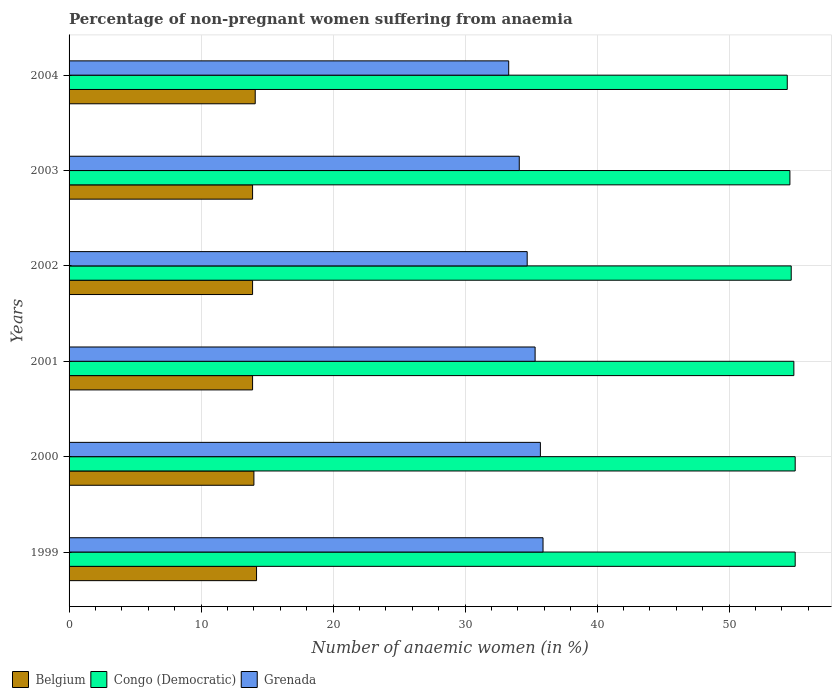How many different coloured bars are there?
Make the answer very short. 3. Are the number of bars on each tick of the Y-axis equal?
Ensure brevity in your answer.  Yes. How many bars are there on the 1st tick from the bottom?
Your response must be concise. 3. What is the label of the 1st group of bars from the top?
Offer a very short reply. 2004. What is the percentage of non-pregnant women suffering from anaemia in Congo (Democratic) in 2001?
Your response must be concise. 54.9. Across all years, what is the maximum percentage of non-pregnant women suffering from anaemia in Belgium?
Give a very brief answer. 14.2. Across all years, what is the minimum percentage of non-pregnant women suffering from anaemia in Congo (Democratic)?
Offer a terse response. 54.4. What is the total percentage of non-pregnant women suffering from anaemia in Belgium in the graph?
Provide a succinct answer. 84. What is the difference between the percentage of non-pregnant women suffering from anaemia in Grenada in 2002 and that in 2004?
Offer a very short reply. 1.4. What is the difference between the percentage of non-pregnant women suffering from anaemia in Grenada in 2003 and the percentage of non-pregnant women suffering from anaemia in Belgium in 2002?
Provide a short and direct response. 20.2. What is the average percentage of non-pregnant women suffering from anaemia in Congo (Democratic) per year?
Offer a very short reply. 54.77. In the year 2000, what is the difference between the percentage of non-pregnant women suffering from anaemia in Congo (Democratic) and percentage of non-pregnant women suffering from anaemia in Grenada?
Your answer should be compact. 19.3. In how many years, is the percentage of non-pregnant women suffering from anaemia in Grenada greater than 50 %?
Your response must be concise. 0. What is the ratio of the percentage of non-pregnant women suffering from anaemia in Grenada in 2001 to that in 2004?
Provide a short and direct response. 1.06. Is the percentage of non-pregnant women suffering from anaemia in Belgium in 1999 less than that in 2001?
Your response must be concise. No. What is the difference between the highest and the second highest percentage of non-pregnant women suffering from anaemia in Belgium?
Your answer should be very brief. 0.1. What is the difference between the highest and the lowest percentage of non-pregnant women suffering from anaemia in Belgium?
Give a very brief answer. 0.3. Is the sum of the percentage of non-pregnant women suffering from anaemia in Grenada in 1999 and 2004 greater than the maximum percentage of non-pregnant women suffering from anaemia in Belgium across all years?
Your response must be concise. Yes. What does the 1st bar from the top in 2000 represents?
Make the answer very short. Grenada. What does the 2nd bar from the bottom in 2002 represents?
Your response must be concise. Congo (Democratic). Is it the case that in every year, the sum of the percentage of non-pregnant women suffering from anaemia in Belgium and percentage of non-pregnant women suffering from anaemia in Congo (Democratic) is greater than the percentage of non-pregnant women suffering from anaemia in Grenada?
Your answer should be very brief. Yes. Are all the bars in the graph horizontal?
Ensure brevity in your answer.  Yes. Are the values on the major ticks of X-axis written in scientific E-notation?
Offer a very short reply. No. How many legend labels are there?
Make the answer very short. 3. What is the title of the graph?
Your response must be concise. Percentage of non-pregnant women suffering from anaemia. Does "Madagascar" appear as one of the legend labels in the graph?
Make the answer very short. No. What is the label or title of the X-axis?
Make the answer very short. Number of anaemic women (in %). What is the label or title of the Y-axis?
Provide a succinct answer. Years. What is the Number of anaemic women (in %) in Congo (Democratic) in 1999?
Make the answer very short. 55. What is the Number of anaemic women (in %) of Grenada in 1999?
Provide a succinct answer. 35.9. What is the Number of anaemic women (in %) in Belgium in 2000?
Your answer should be compact. 14. What is the Number of anaemic women (in %) of Grenada in 2000?
Your answer should be very brief. 35.7. What is the Number of anaemic women (in %) of Belgium in 2001?
Give a very brief answer. 13.9. What is the Number of anaemic women (in %) of Congo (Democratic) in 2001?
Offer a very short reply. 54.9. What is the Number of anaemic women (in %) in Grenada in 2001?
Your answer should be compact. 35.3. What is the Number of anaemic women (in %) of Congo (Democratic) in 2002?
Your response must be concise. 54.7. What is the Number of anaemic women (in %) in Grenada in 2002?
Make the answer very short. 34.7. What is the Number of anaemic women (in %) in Congo (Democratic) in 2003?
Offer a terse response. 54.6. What is the Number of anaemic women (in %) in Grenada in 2003?
Offer a very short reply. 34.1. What is the Number of anaemic women (in %) in Congo (Democratic) in 2004?
Provide a short and direct response. 54.4. What is the Number of anaemic women (in %) of Grenada in 2004?
Offer a terse response. 33.3. Across all years, what is the maximum Number of anaemic women (in %) in Belgium?
Offer a very short reply. 14.2. Across all years, what is the maximum Number of anaemic women (in %) of Congo (Democratic)?
Your answer should be very brief. 55. Across all years, what is the maximum Number of anaemic women (in %) in Grenada?
Ensure brevity in your answer.  35.9. Across all years, what is the minimum Number of anaemic women (in %) of Congo (Democratic)?
Give a very brief answer. 54.4. Across all years, what is the minimum Number of anaemic women (in %) of Grenada?
Make the answer very short. 33.3. What is the total Number of anaemic women (in %) of Congo (Democratic) in the graph?
Make the answer very short. 328.6. What is the total Number of anaemic women (in %) of Grenada in the graph?
Your response must be concise. 209. What is the difference between the Number of anaemic women (in %) in Congo (Democratic) in 1999 and that in 2000?
Keep it short and to the point. 0. What is the difference between the Number of anaemic women (in %) in Grenada in 1999 and that in 2000?
Give a very brief answer. 0.2. What is the difference between the Number of anaemic women (in %) in Belgium in 1999 and that in 2001?
Provide a short and direct response. 0.3. What is the difference between the Number of anaemic women (in %) in Congo (Democratic) in 1999 and that in 2001?
Your answer should be compact. 0.1. What is the difference between the Number of anaemic women (in %) of Grenada in 1999 and that in 2001?
Provide a succinct answer. 0.6. What is the difference between the Number of anaemic women (in %) in Congo (Democratic) in 1999 and that in 2002?
Provide a succinct answer. 0.3. What is the difference between the Number of anaemic women (in %) in Grenada in 1999 and that in 2003?
Offer a very short reply. 1.8. What is the difference between the Number of anaemic women (in %) of Belgium in 1999 and that in 2004?
Your answer should be compact. 0.1. What is the difference between the Number of anaemic women (in %) in Belgium in 2000 and that in 2001?
Your answer should be very brief. 0.1. What is the difference between the Number of anaemic women (in %) of Congo (Democratic) in 2000 and that in 2001?
Give a very brief answer. 0.1. What is the difference between the Number of anaemic women (in %) of Congo (Democratic) in 2000 and that in 2003?
Your answer should be very brief. 0.4. What is the difference between the Number of anaemic women (in %) of Belgium in 2000 and that in 2004?
Offer a terse response. -0.1. What is the difference between the Number of anaemic women (in %) of Grenada in 2000 and that in 2004?
Make the answer very short. 2.4. What is the difference between the Number of anaemic women (in %) in Belgium in 2001 and that in 2002?
Ensure brevity in your answer.  0. What is the difference between the Number of anaemic women (in %) in Congo (Democratic) in 2001 and that in 2002?
Make the answer very short. 0.2. What is the difference between the Number of anaemic women (in %) of Grenada in 2001 and that in 2003?
Your answer should be compact. 1.2. What is the difference between the Number of anaemic women (in %) of Congo (Democratic) in 2001 and that in 2004?
Offer a very short reply. 0.5. What is the difference between the Number of anaemic women (in %) in Congo (Democratic) in 2002 and that in 2003?
Your response must be concise. 0.1. What is the difference between the Number of anaemic women (in %) in Grenada in 2002 and that in 2004?
Offer a very short reply. 1.4. What is the difference between the Number of anaemic women (in %) in Grenada in 2003 and that in 2004?
Your response must be concise. 0.8. What is the difference between the Number of anaemic women (in %) in Belgium in 1999 and the Number of anaemic women (in %) in Congo (Democratic) in 2000?
Offer a terse response. -40.8. What is the difference between the Number of anaemic women (in %) in Belgium in 1999 and the Number of anaemic women (in %) in Grenada in 2000?
Ensure brevity in your answer.  -21.5. What is the difference between the Number of anaemic women (in %) of Congo (Democratic) in 1999 and the Number of anaemic women (in %) of Grenada in 2000?
Offer a terse response. 19.3. What is the difference between the Number of anaemic women (in %) in Belgium in 1999 and the Number of anaemic women (in %) in Congo (Democratic) in 2001?
Keep it short and to the point. -40.7. What is the difference between the Number of anaemic women (in %) in Belgium in 1999 and the Number of anaemic women (in %) in Grenada in 2001?
Keep it short and to the point. -21.1. What is the difference between the Number of anaemic women (in %) in Congo (Democratic) in 1999 and the Number of anaemic women (in %) in Grenada in 2001?
Offer a terse response. 19.7. What is the difference between the Number of anaemic women (in %) in Belgium in 1999 and the Number of anaemic women (in %) in Congo (Democratic) in 2002?
Offer a terse response. -40.5. What is the difference between the Number of anaemic women (in %) of Belgium in 1999 and the Number of anaemic women (in %) of Grenada in 2002?
Provide a short and direct response. -20.5. What is the difference between the Number of anaemic women (in %) in Congo (Democratic) in 1999 and the Number of anaemic women (in %) in Grenada in 2002?
Your answer should be compact. 20.3. What is the difference between the Number of anaemic women (in %) of Belgium in 1999 and the Number of anaemic women (in %) of Congo (Democratic) in 2003?
Keep it short and to the point. -40.4. What is the difference between the Number of anaemic women (in %) of Belgium in 1999 and the Number of anaemic women (in %) of Grenada in 2003?
Offer a terse response. -19.9. What is the difference between the Number of anaemic women (in %) of Congo (Democratic) in 1999 and the Number of anaemic women (in %) of Grenada in 2003?
Ensure brevity in your answer.  20.9. What is the difference between the Number of anaemic women (in %) in Belgium in 1999 and the Number of anaemic women (in %) in Congo (Democratic) in 2004?
Offer a terse response. -40.2. What is the difference between the Number of anaemic women (in %) of Belgium in 1999 and the Number of anaemic women (in %) of Grenada in 2004?
Provide a succinct answer. -19.1. What is the difference between the Number of anaemic women (in %) in Congo (Democratic) in 1999 and the Number of anaemic women (in %) in Grenada in 2004?
Ensure brevity in your answer.  21.7. What is the difference between the Number of anaemic women (in %) in Belgium in 2000 and the Number of anaemic women (in %) in Congo (Democratic) in 2001?
Give a very brief answer. -40.9. What is the difference between the Number of anaemic women (in %) of Belgium in 2000 and the Number of anaemic women (in %) of Grenada in 2001?
Your answer should be very brief. -21.3. What is the difference between the Number of anaemic women (in %) of Belgium in 2000 and the Number of anaemic women (in %) of Congo (Democratic) in 2002?
Keep it short and to the point. -40.7. What is the difference between the Number of anaemic women (in %) in Belgium in 2000 and the Number of anaemic women (in %) in Grenada in 2002?
Your response must be concise. -20.7. What is the difference between the Number of anaemic women (in %) of Congo (Democratic) in 2000 and the Number of anaemic women (in %) of Grenada in 2002?
Offer a very short reply. 20.3. What is the difference between the Number of anaemic women (in %) of Belgium in 2000 and the Number of anaemic women (in %) of Congo (Democratic) in 2003?
Your answer should be compact. -40.6. What is the difference between the Number of anaemic women (in %) in Belgium in 2000 and the Number of anaemic women (in %) in Grenada in 2003?
Keep it short and to the point. -20.1. What is the difference between the Number of anaemic women (in %) of Congo (Democratic) in 2000 and the Number of anaemic women (in %) of Grenada in 2003?
Your answer should be compact. 20.9. What is the difference between the Number of anaemic women (in %) of Belgium in 2000 and the Number of anaemic women (in %) of Congo (Democratic) in 2004?
Offer a very short reply. -40.4. What is the difference between the Number of anaemic women (in %) of Belgium in 2000 and the Number of anaemic women (in %) of Grenada in 2004?
Give a very brief answer. -19.3. What is the difference between the Number of anaemic women (in %) of Congo (Democratic) in 2000 and the Number of anaemic women (in %) of Grenada in 2004?
Provide a succinct answer. 21.7. What is the difference between the Number of anaemic women (in %) in Belgium in 2001 and the Number of anaemic women (in %) in Congo (Democratic) in 2002?
Your answer should be compact. -40.8. What is the difference between the Number of anaemic women (in %) in Belgium in 2001 and the Number of anaemic women (in %) in Grenada in 2002?
Offer a terse response. -20.8. What is the difference between the Number of anaemic women (in %) of Congo (Democratic) in 2001 and the Number of anaemic women (in %) of Grenada in 2002?
Make the answer very short. 20.2. What is the difference between the Number of anaemic women (in %) of Belgium in 2001 and the Number of anaemic women (in %) of Congo (Democratic) in 2003?
Your answer should be very brief. -40.7. What is the difference between the Number of anaemic women (in %) of Belgium in 2001 and the Number of anaemic women (in %) of Grenada in 2003?
Offer a terse response. -20.2. What is the difference between the Number of anaemic women (in %) in Congo (Democratic) in 2001 and the Number of anaemic women (in %) in Grenada in 2003?
Provide a succinct answer. 20.8. What is the difference between the Number of anaemic women (in %) in Belgium in 2001 and the Number of anaemic women (in %) in Congo (Democratic) in 2004?
Give a very brief answer. -40.5. What is the difference between the Number of anaemic women (in %) in Belgium in 2001 and the Number of anaemic women (in %) in Grenada in 2004?
Your answer should be very brief. -19.4. What is the difference between the Number of anaemic women (in %) of Congo (Democratic) in 2001 and the Number of anaemic women (in %) of Grenada in 2004?
Offer a terse response. 21.6. What is the difference between the Number of anaemic women (in %) in Belgium in 2002 and the Number of anaemic women (in %) in Congo (Democratic) in 2003?
Keep it short and to the point. -40.7. What is the difference between the Number of anaemic women (in %) in Belgium in 2002 and the Number of anaemic women (in %) in Grenada in 2003?
Offer a terse response. -20.2. What is the difference between the Number of anaemic women (in %) of Congo (Democratic) in 2002 and the Number of anaemic women (in %) of Grenada in 2003?
Your answer should be compact. 20.6. What is the difference between the Number of anaemic women (in %) of Belgium in 2002 and the Number of anaemic women (in %) of Congo (Democratic) in 2004?
Give a very brief answer. -40.5. What is the difference between the Number of anaemic women (in %) of Belgium in 2002 and the Number of anaemic women (in %) of Grenada in 2004?
Ensure brevity in your answer.  -19.4. What is the difference between the Number of anaemic women (in %) of Congo (Democratic) in 2002 and the Number of anaemic women (in %) of Grenada in 2004?
Give a very brief answer. 21.4. What is the difference between the Number of anaemic women (in %) of Belgium in 2003 and the Number of anaemic women (in %) of Congo (Democratic) in 2004?
Ensure brevity in your answer.  -40.5. What is the difference between the Number of anaemic women (in %) in Belgium in 2003 and the Number of anaemic women (in %) in Grenada in 2004?
Keep it short and to the point. -19.4. What is the difference between the Number of anaemic women (in %) in Congo (Democratic) in 2003 and the Number of anaemic women (in %) in Grenada in 2004?
Offer a very short reply. 21.3. What is the average Number of anaemic women (in %) in Congo (Democratic) per year?
Offer a very short reply. 54.77. What is the average Number of anaemic women (in %) of Grenada per year?
Your answer should be very brief. 34.83. In the year 1999, what is the difference between the Number of anaemic women (in %) in Belgium and Number of anaemic women (in %) in Congo (Democratic)?
Offer a very short reply. -40.8. In the year 1999, what is the difference between the Number of anaemic women (in %) in Belgium and Number of anaemic women (in %) in Grenada?
Your answer should be compact. -21.7. In the year 2000, what is the difference between the Number of anaemic women (in %) of Belgium and Number of anaemic women (in %) of Congo (Democratic)?
Your answer should be compact. -41. In the year 2000, what is the difference between the Number of anaemic women (in %) of Belgium and Number of anaemic women (in %) of Grenada?
Offer a terse response. -21.7. In the year 2000, what is the difference between the Number of anaemic women (in %) in Congo (Democratic) and Number of anaemic women (in %) in Grenada?
Give a very brief answer. 19.3. In the year 2001, what is the difference between the Number of anaemic women (in %) of Belgium and Number of anaemic women (in %) of Congo (Democratic)?
Keep it short and to the point. -41. In the year 2001, what is the difference between the Number of anaemic women (in %) in Belgium and Number of anaemic women (in %) in Grenada?
Your answer should be very brief. -21.4. In the year 2001, what is the difference between the Number of anaemic women (in %) in Congo (Democratic) and Number of anaemic women (in %) in Grenada?
Provide a succinct answer. 19.6. In the year 2002, what is the difference between the Number of anaemic women (in %) of Belgium and Number of anaemic women (in %) of Congo (Democratic)?
Offer a terse response. -40.8. In the year 2002, what is the difference between the Number of anaemic women (in %) in Belgium and Number of anaemic women (in %) in Grenada?
Offer a very short reply. -20.8. In the year 2002, what is the difference between the Number of anaemic women (in %) of Congo (Democratic) and Number of anaemic women (in %) of Grenada?
Your answer should be compact. 20. In the year 2003, what is the difference between the Number of anaemic women (in %) of Belgium and Number of anaemic women (in %) of Congo (Democratic)?
Your answer should be compact. -40.7. In the year 2003, what is the difference between the Number of anaemic women (in %) in Belgium and Number of anaemic women (in %) in Grenada?
Your response must be concise. -20.2. In the year 2004, what is the difference between the Number of anaemic women (in %) of Belgium and Number of anaemic women (in %) of Congo (Democratic)?
Keep it short and to the point. -40.3. In the year 2004, what is the difference between the Number of anaemic women (in %) of Belgium and Number of anaemic women (in %) of Grenada?
Provide a short and direct response. -19.2. In the year 2004, what is the difference between the Number of anaemic women (in %) in Congo (Democratic) and Number of anaemic women (in %) in Grenada?
Make the answer very short. 21.1. What is the ratio of the Number of anaemic women (in %) in Belgium in 1999 to that in 2000?
Make the answer very short. 1.01. What is the ratio of the Number of anaemic women (in %) of Grenada in 1999 to that in 2000?
Offer a very short reply. 1.01. What is the ratio of the Number of anaemic women (in %) of Belgium in 1999 to that in 2001?
Provide a short and direct response. 1.02. What is the ratio of the Number of anaemic women (in %) of Congo (Democratic) in 1999 to that in 2001?
Offer a very short reply. 1. What is the ratio of the Number of anaemic women (in %) in Belgium in 1999 to that in 2002?
Offer a very short reply. 1.02. What is the ratio of the Number of anaemic women (in %) in Grenada in 1999 to that in 2002?
Your answer should be very brief. 1.03. What is the ratio of the Number of anaemic women (in %) of Belgium in 1999 to that in 2003?
Keep it short and to the point. 1.02. What is the ratio of the Number of anaemic women (in %) of Congo (Democratic) in 1999 to that in 2003?
Provide a succinct answer. 1.01. What is the ratio of the Number of anaemic women (in %) in Grenada in 1999 to that in 2003?
Your response must be concise. 1.05. What is the ratio of the Number of anaemic women (in %) of Belgium in 1999 to that in 2004?
Keep it short and to the point. 1.01. What is the ratio of the Number of anaemic women (in %) of Grenada in 1999 to that in 2004?
Provide a succinct answer. 1.08. What is the ratio of the Number of anaemic women (in %) in Congo (Democratic) in 2000 to that in 2001?
Offer a very short reply. 1. What is the ratio of the Number of anaemic women (in %) in Grenada in 2000 to that in 2001?
Provide a succinct answer. 1.01. What is the ratio of the Number of anaemic women (in %) in Grenada in 2000 to that in 2002?
Your answer should be compact. 1.03. What is the ratio of the Number of anaemic women (in %) of Belgium in 2000 to that in 2003?
Your response must be concise. 1.01. What is the ratio of the Number of anaemic women (in %) in Congo (Democratic) in 2000 to that in 2003?
Your response must be concise. 1.01. What is the ratio of the Number of anaemic women (in %) in Grenada in 2000 to that in 2003?
Offer a very short reply. 1.05. What is the ratio of the Number of anaemic women (in %) in Grenada in 2000 to that in 2004?
Keep it short and to the point. 1.07. What is the ratio of the Number of anaemic women (in %) in Grenada in 2001 to that in 2002?
Ensure brevity in your answer.  1.02. What is the ratio of the Number of anaemic women (in %) of Grenada in 2001 to that in 2003?
Your answer should be compact. 1.04. What is the ratio of the Number of anaemic women (in %) in Belgium in 2001 to that in 2004?
Offer a terse response. 0.99. What is the ratio of the Number of anaemic women (in %) in Congo (Democratic) in 2001 to that in 2004?
Offer a terse response. 1.01. What is the ratio of the Number of anaemic women (in %) in Grenada in 2001 to that in 2004?
Offer a terse response. 1.06. What is the ratio of the Number of anaemic women (in %) of Congo (Democratic) in 2002 to that in 2003?
Your answer should be very brief. 1. What is the ratio of the Number of anaemic women (in %) of Grenada in 2002 to that in 2003?
Offer a terse response. 1.02. What is the ratio of the Number of anaemic women (in %) in Belgium in 2002 to that in 2004?
Offer a very short reply. 0.99. What is the ratio of the Number of anaemic women (in %) in Congo (Democratic) in 2002 to that in 2004?
Keep it short and to the point. 1.01. What is the ratio of the Number of anaemic women (in %) of Grenada in 2002 to that in 2004?
Offer a terse response. 1.04. What is the ratio of the Number of anaemic women (in %) in Belgium in 2003 to that in 2004?
Provide a short and direct response. 0.99. What is the ratio of the Number of anaemic women (in %) in Grenada in 2003 to that in 2004?
Your answer should be very brief. 1.02. What is the difference between the highest and the second highest Number of anaemic women (in %) in Belgium?
Keep it short and to the point. 0.1. What is the difference between the highest and the second highest Number of anaemic women (in %) of Congo (Democratic)?
Make the answer very short. 0. What is the difference between the highest and the lowest Number of anaemic women (in %) in Grenada?
Provide a short and direct response. 2.6. 